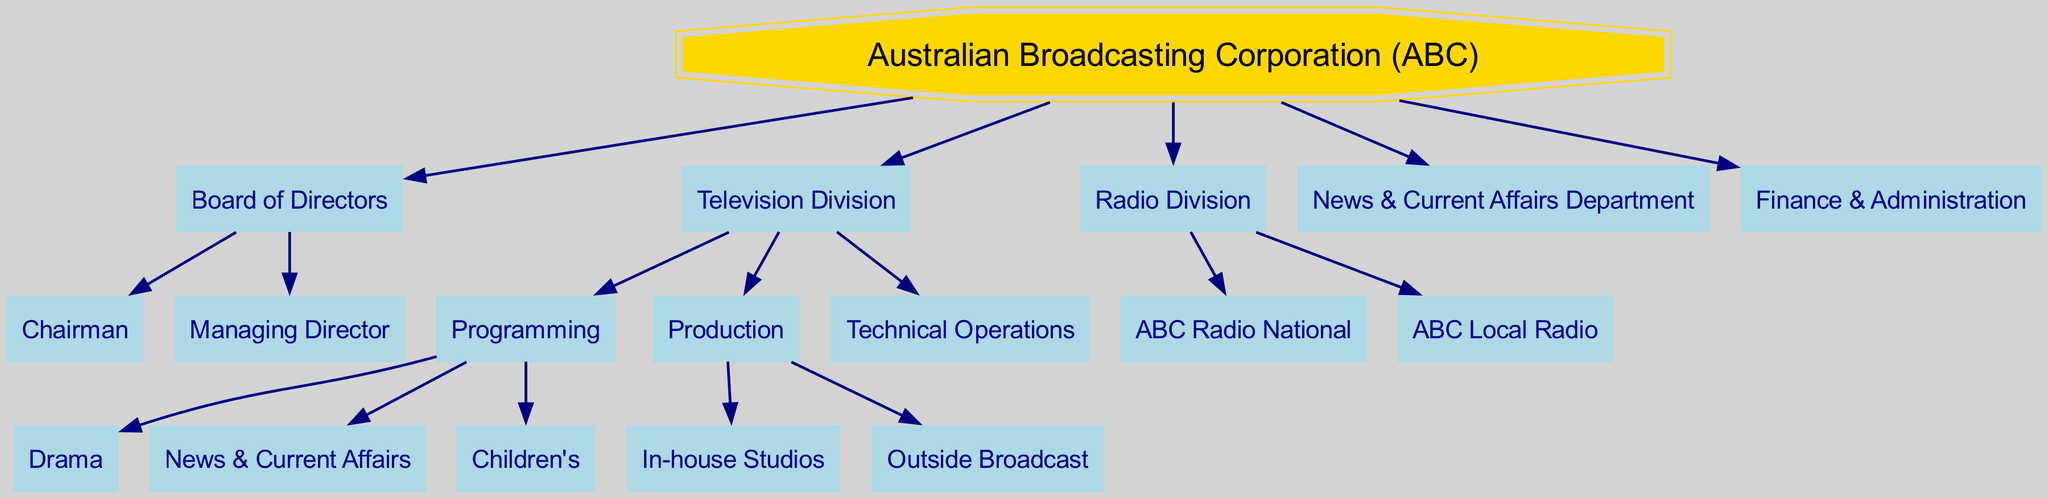What is the root node in the diagram? The root node is the topmost node in the hierarchical structure, which represents the main organization. In this case, it is labeled "Australian Broadcasting Corporation (ABC)".
Answer: Australian Broadcasting Corporation (ABC) How many divisions does the Australian Broadcasting Corporation have? The diagram shows two primary divisions: the Television Division and the Radio Division. Thus, by counting these nodes, we identify two distinct divisions.
Answer: 2 Who is at the top of the Board of Directors? The diagram indicates that the "Chairman" is at the top of the Board of Directors, as it is one of the direct children of the Board node.
Answer: Chairman What are the two types of operations listed under the Production section of the Television Division? The Production section lists "In-house Studios" and "Outside Broadcast" as its two children, indicating these types of operations under this division.
Answer: In-house Studios, Outside Broadcast Which department focuses on "News & Current Affairs"? The diagram includes a node labeled "News & Current Affairs Department," which specifies that this department is dedicated specifically to news and current affairs.
Answer: News & Current Affairs Department How many total nodes are under the Television Division? Within the Television Division, there are three nodes under Programming (Drama, News & Current Affairs, Children's) and two under Production (In-house Studios, Outside Broadcast), plus one Technical Operations node, giving a total count of six nodes.
Answer: 6 What is the relationship between the Television Division and the Radio Division? Both the Television Division and the Radio Division are direct children of the root node, indicating they are peer divisions within the overall structure of the Australian Broadcasting Corporation.
Answer: Peer divisions Which division would you associate with the "Technical Operations"? The "Technical Operations" node is a child of the Television Division, indicating that it falls under this specific division's responsibilities.
Answer: Television Division Which executive role comes directly below the Chairman? The "Managing Director" is the role that is listed directly below the Chairman in the Board of Directors structure, showing its subordinate position within the hierarchy.
Answer: Managing Director 